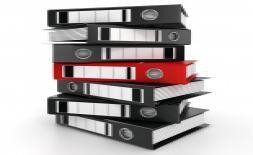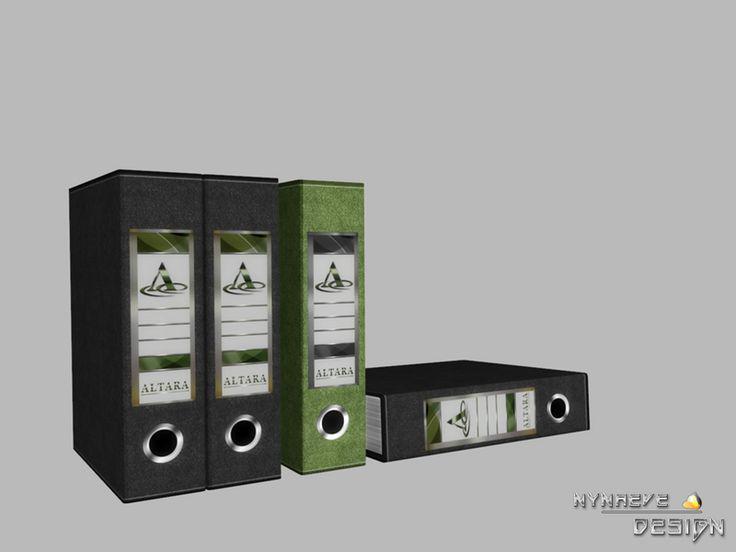The first image is the image on the left, the second image is the image on the right. Assess this claim about the two images: "The left image contains a person seated behind a stack of binders.". Correct or not? Answer yes or no. No. The first image is the image on the left, the second image is the image on the right. Analyze the images presented: Is the assertion "Both of the images show binders full of papers." valid? Answer yes or no. No. The first image is the image on the left, the second image is the image on the right. For the images displayed, is the sentence "A person is sitting behind a stack of binders in one of the images." factually correct? Answer yes or no. No. 